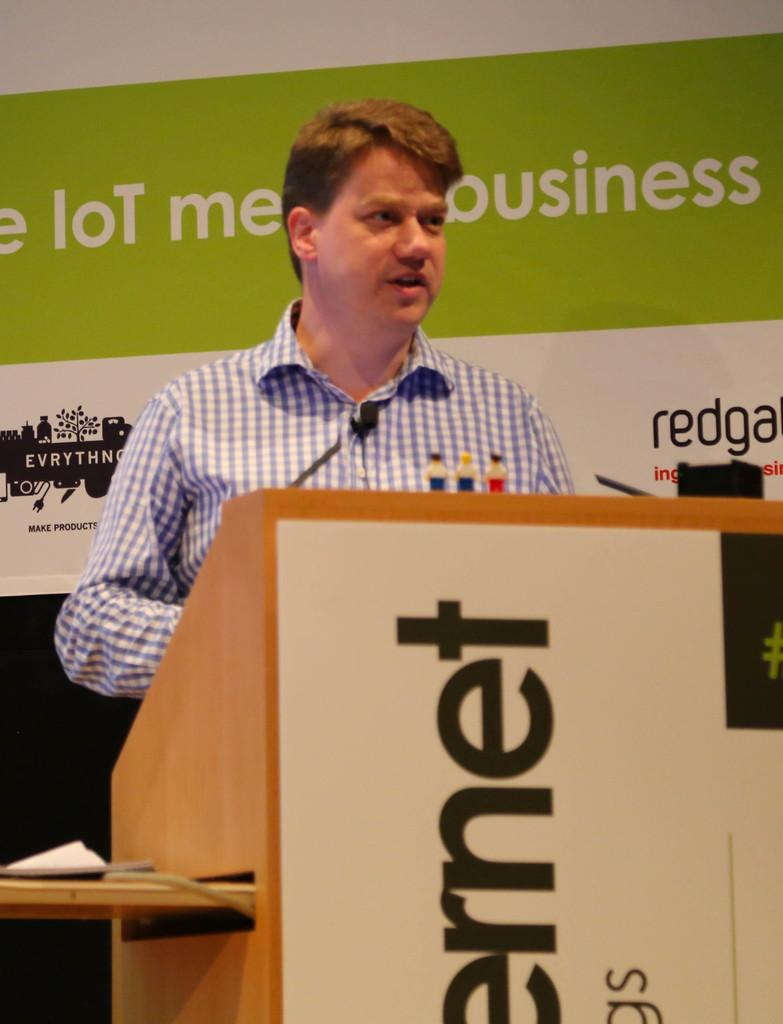<image>
Write a terse but informative summary of the picture. A man stands behind a podium giving a speech. Behind him is a green and white wall that appears to say IoT means business. 